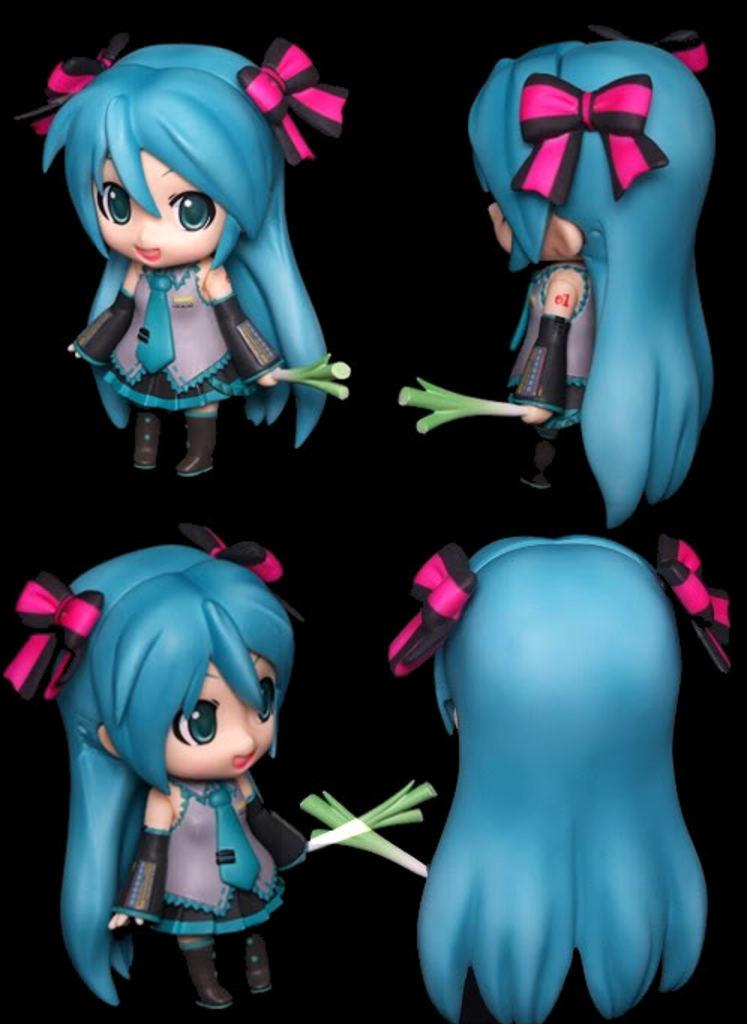How many toys are present in the image? There are four toys in the image. What colors are the toys? The toys are in black, blue, and ash colors. What are the toys holding? The toys are holding white and green color objects. What is the color of the background in the image? The background of the image is black. What type of fiction is the toys reading in the image? There is no indication in the image that the toys are reading any fiction. Can you see any pickles in the image? There are no pickles present in the image. 